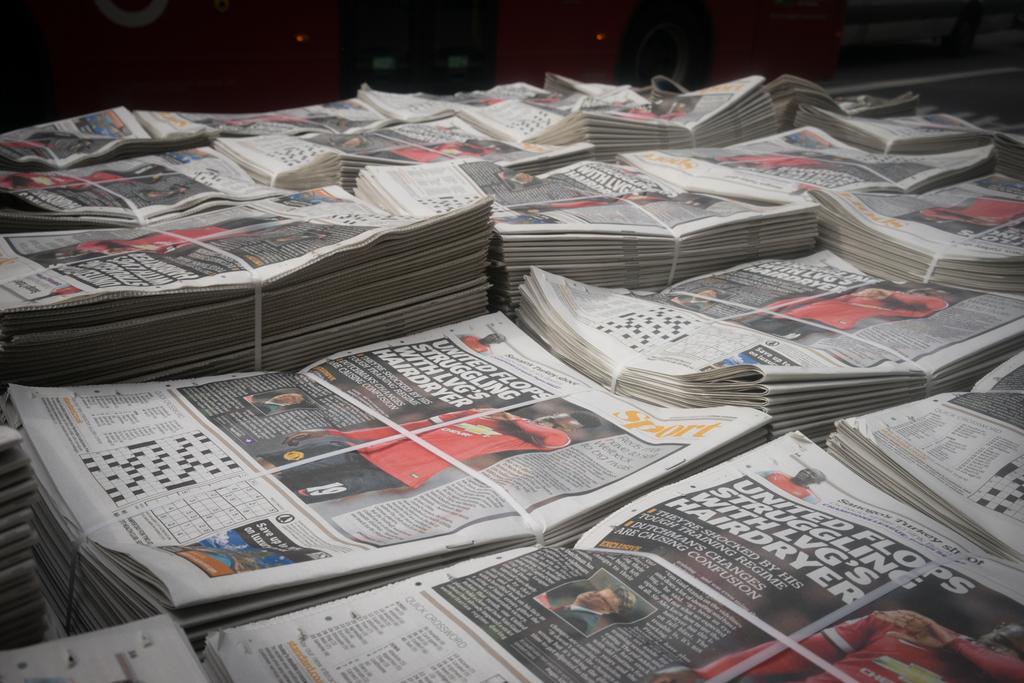What personal grooming item is referenced in the main story's title?
Offer a terse response. Hairdryer. Is does the gold test say on the paper?
Offer a very short reply. Sport. 